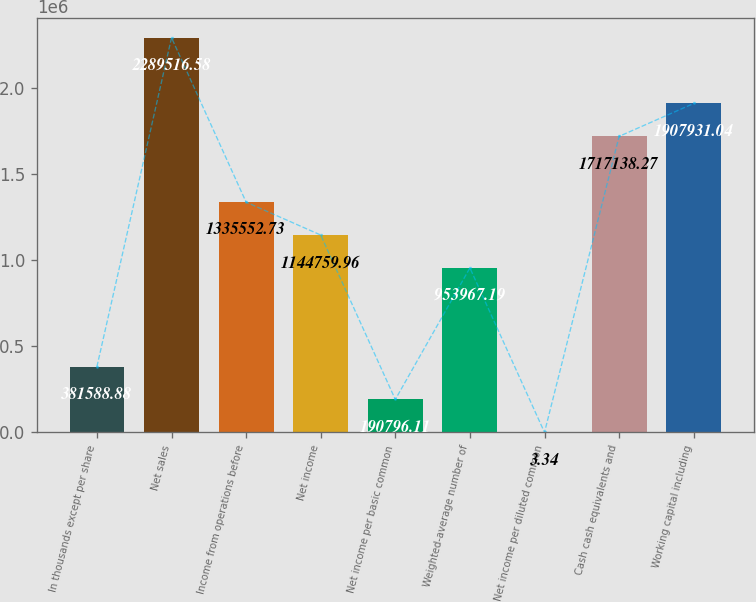<chart> <loc_0><loc_0><loc_500><loc_500><bar_chart><fcel>In thousands except per share<fcel>Net sales<fcel>Income from operations before<fcel>Net income<fcel>Net income per basic common<fcel>Weighted-average number of<fcel>Net income per diluted common<fcel>Cash cash equivalents and<fcel>Working capital including<nl><fcel>381589<fcel>2.28952e+06<fcel>1.33555e+06<fcel>1.14476e+06<fcel>190796<fcel>953967<fcel>3.34<fcel>1.71714e+06<fcel>1.90793e+06<nl></chart> 